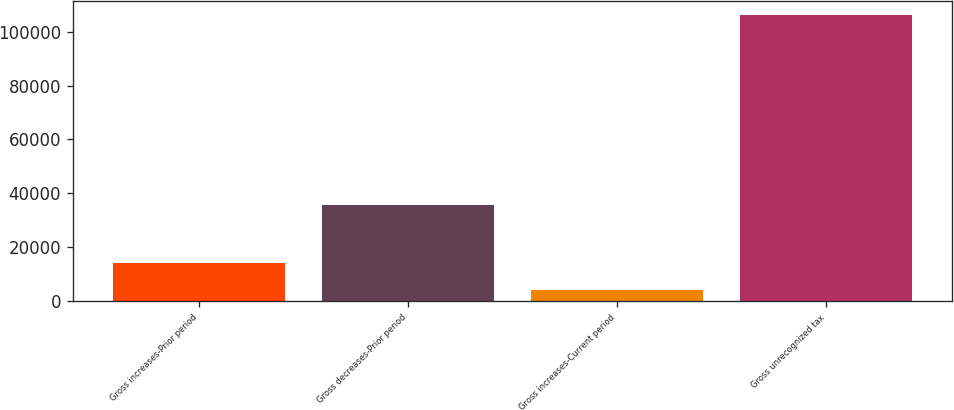<chart> <loc_0><loc_0><loc_500><loc_500><bar_chart><fcel>Gross increases-Prior period<fcel>Gross decreases-Prior period<fcel>Gross increases-Current period<fcel>Gross unrecognized tax<nl><fcel>14282.2<fcel>35508<fcel>4064<fcel>106246<nl></chart> 